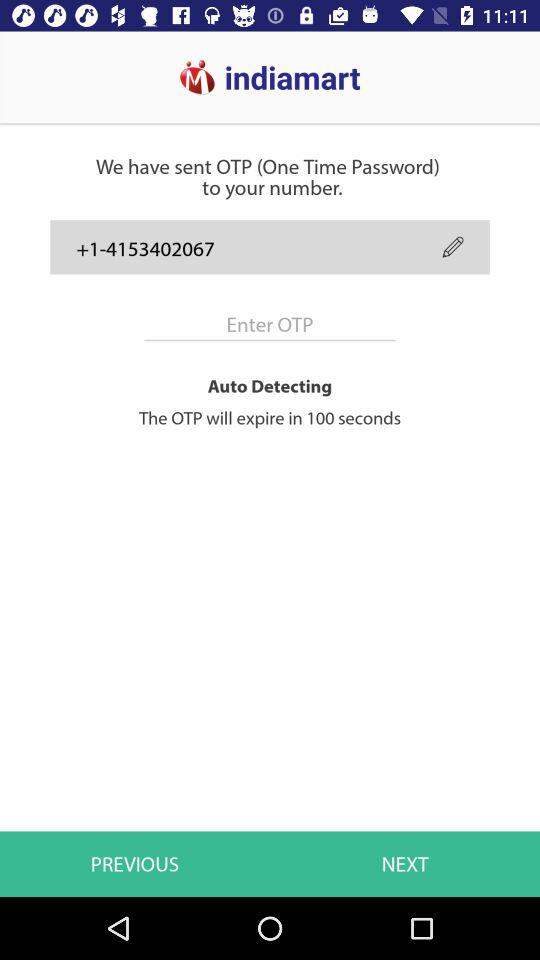What is the name of the application? The name of the application is "indiamart". 